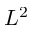Convert formula to latex. <formula><loc_0><loc_0><loc_500><loc_500>L ^ { 2 }</formula> 